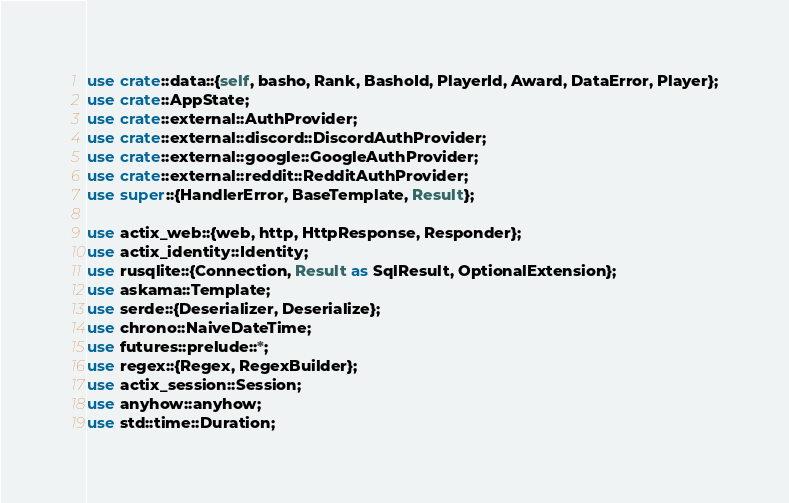<code> <loc_0><loc_0><loc_500><loc_500><_Rust_>
use crate::data::{self, basho, Rank, BashoId, PlayerId, Award, DataError, Player};
use crate::AppState;
use crate::external::AuthProvider;
use crate::external::discord::DiscordAuthProvider;
use crate::external::google::GoogleAuthProvider;
use crate::external::reddit::RedditAuthProvider;
use super::{HandlerError, BaseTemplate, Result};

use actix_web::{web, http, HttpResponse, Responder};
use actix_identity::Identity;
use rusqlite::{Connection, Result as SqlResult, OptionalExtension};
use askama::Template;
use serde::{Deserializer, Deserialize};
use chrono::NaiveDateTime;
use futures::prelude::*;
use regex::{Regex, RegexBuilder};
use actix_session::Session;
use anyhow::anyhow;
use std::time::Duration;
</code> 